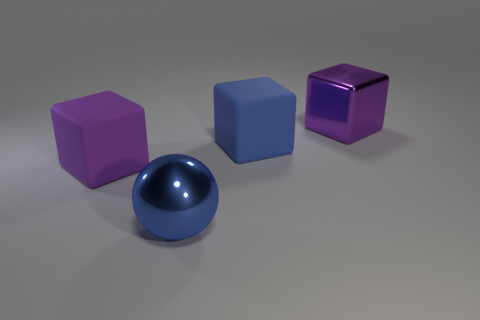Is the size of the rubber thing that is to the left of the large blue ball the same as the purple object that is to the right of the blue metallic thing?
Your answer should be very brief. Yes. Are there more matte objects behind the big purple metallic cube than blue metallic objects behind the blue metallic thing?
Keep it short and to the point. No. How many other objects are the same color as the ball?
Your answer should be compact. 1. Does the sphere have the same color as the rubber object right of the blue shiny object?
Ensure brevity in your answer.  Yes. There is a big blue object that is on the left side of the blue rubber block; how many large purple metal blocks are right of it?
Provide a succinct answer. 1. The big blue thing that is behind the large metallic thing in front of the purple cube on the right side of the big blue matte block is made of what material?
Your answer should be very brief. Rubber. There is a big thing that is on the right side of the ball and left of the big metal cube; what is it made of?
Make the answer very short. Rubber. What number of tiny blue objects are the same shape as the big purple rubber thing?
Your answer should be very brief. 0. How big is the purple block in front of the big rubber object to the right of the big purple matte block?
Provide a succinct answer. Large. There is a big shiny object to the left of the purple metallic object; does it have the same color as the big rubber thing right of the purple matte thing?
Ensure brevity in your answer.  Yes. 